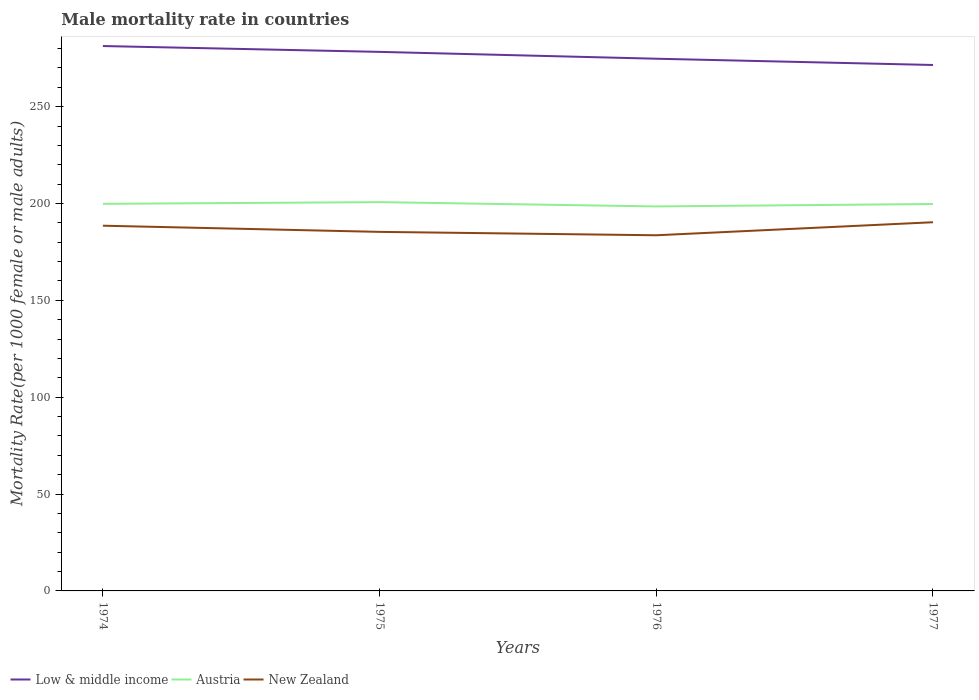How many different coloured lines are there?
Your answer should be compact. 3. Is the number of lines equal to the number of legend labels?
Your answer should be very brief. Yes. Across all years, what is the maximum male mortality rate in New Zealand?
Offer a terse response. 183.61. In which year was the male mortality rate in New Zealand maximum?
Ensure brevity in your answer.  1976. What is the total male mortality rate in Austria in the graph?
Provide a short and direct response. 2.21. What is the difference between the highest and the second highest male mortality rate in Low & middle income?
Provide a short and direct response. 9.78. What is the difference between the highest and the lowest male mortality rate in New Zealand?
Give a very brief answer. 2. How many years are there in the graph?
Make the answer very short. 4. What is the difference between two consecutive major ticks on the Y-axis?
Your answer should be compact. 50. Does the graph contain grids?
Offer a very short reply. No. What is the title of the graph?
Your answer should be compact. Male mortality rate in countries. What is the label or title of the X-axis?
Offer a very short reply. Years. What is the label or title of the Y-axis?
Offer a very short reply. Mortality Rate(per 1000 female or male adults). What is the Mortality Rate(per 1000 female or male adults) of Low & middle income in 1974?
Ensure brevity in your answer.  281.3. What is the Mortality Rate(per 1000 female or male adults) in Austria in 1974?
Give a very brief answer. 199.84. What is the Mortality Rate(per 1000 female or male adults) of New Zealand in 1974?
Provide a succinct answer. 188.54. What is the Mortality Rate(per 1000 female or male adults) of Low & middle income in 1975?
Ensure brevity in your answer.  278.28. What is the Mortality Rate(per 1000 female or male adults) of Austria in 1975?
Make the answer very short. 200.71. What is the Mortality Rate(per 1000 female or male adults) in New Zealand in 1975?
Keep it short and to the point. 185.37. What is the Mortality Rate(per 1000 female or male adults) in Low & middle income in 1976?
Your answer should be compact. 274.75. What is the Mortality Rate(per 1000 female or male adults) in Austria in 1976?
Keep it short and to the point. 198.5. What is the Mortality Rate(per 1000 female or male adults) in New Zealand in 1976?
Provide a short and direct response. 183.61. What is the Mortality Rate(per 1000 female or male adults) of Low & middle income in 1977?
Provide a succinct answer. 271.52. What is the Mortality Rate(per 1000 female or male adults) of Austria in 1977?
Give a very brief answer. 199.75. What is the Mortality Rate(per 1000 female or male adults) in New Zealand in 1977?
Your answer should be very brief. 190.34. Across all years, what is the maximum Mortality Rate(per 1000 female or male adults) of Low & middle income?
Provide a short and direct response. 281.3. Across all years, what is the maximum Mortality Rate(per 1000 female or male adults) of Austria?
Your answer should be compact. 200.71. Across all years, what is the maximum Mortality Rate(per 1000 female or male adults) in New Zealand?
Your answer should be very brief. 190.34. Across all years, what is the minimum Mortality Rate(per 1000 female or male adults) in Low & middle income?
Make the answer very short. 271.52. Across all years, what is the minimum Mortality Rate(per 1000 female or male adults) in Austria?
Your response must be concise. 198.5. Across all years, what is the minimum Mortality Rate(per 1000 female or male adults) of New Zealand?
Provide a short and direct response. 183.61. What is the total Mortality Rate(per 1000 female or male adults) of Low & middle income in the graph?
Your answer should be very brief. 1105.86. What is the total Mortality Rate(per 1000 female or male adults) in Austria in the graph?
Keep it short and to the point. 798.8. What is the total Mortality Rate(per 1000 female or male adults) of New Zealand in the graph?
Your answer should be compact. 747.85. What is the difference between the Mortality Rate(per 1000 female or male adults) of Low & middle income in 1974 and that in 1975?
Offer a very short reply. 3.02. What is the difference between the Mortality Rate(per 1000 female or male adults) in Austria in 1974 and that in 1975?
Offer a terse response. -0.87. What is the difference between the Mortality Rate(per 1000 female or male adults) in New Zealand in 1974 and that in 1975?
Give a very brief answer. 3.18. What is the difference between the Mortality Rate(per 1000 female or male adults) of Low & middle income in 1974 and that in 1976?
Provide a succinct answer. 6.55. What is the difference between the Mortality Rate(per 1000 female or male adults) in Austria in 1974 and that in 1976?
Keep it short and to the point. 1.33. What is the difference between the Mortality Rate(per 1000 female or male adults) of New Zealand in 1974 and that in 1976?
Ensure brevity in your answer.  4.93. What is the difference between the Mortality Rate(per 1000 female or male adults) in Low & middle income in 1974 and that in 1977?
Your response must be concise. 9.78. What is the difference between the Mortality Rate(per 1000 female or male adults) in Austria in 1974 and that in 1977?
Make the answer very short. 0.09. What is the difference between the Mortality Rate(per 1000 female or male adults) of New Zealand in 1974 and that in 1977?
Make the answer very short. -1.79. What is the difference between the Mortality Rate(per 1000 female or male adults) of Low & middle income in 1975 and that in 1976?
Make the answer very short. 3.53. What is the difference between the Mortality Rate(per 1000 female or male adults) of Austria in 1975 and that in 1976?
Provide a short and direct response. 2.21. What is the difference between the Mortality Rate(per 1000 female or male adults) of New Zealand in 1975 and that in 1976?
Your response must be concise. 1.76. What is the difference between the Mortality Rate(per 1000 female or male adults) in Low & middle income in 1975 and that in 1977?
Offer a very short reply. 6.77. What is the difference between the Mortality Rate(per 1000 female or male adults) in New Zealand in 1975 and that in 1977?
Provide a short and direct response. -4.97. What is the difference between the Mortality Rate(per 1000 female or male adults) in Low & middle income in 1976 and that in 1977?
Your answer should be very brief. 3.23. What is the difference between the Mortality Rate(per 1000 female or male adults) of Austria in 1976 and that in 1977?
Provide a short and direct response. -1.24. What is the difference between the Mortality Rate(per 1000 female or male adults) of New Zealand in 1976 and that in 1977?
Offer a very short reply. -6.73. What is the difference between the Mortality Rate(per 1000 female or male adults) in Low & middle income in 1974 and the Mortality Rate(per 1000 female or male adults) in Austria in 1975?
Provide a short and direct response. 80.59. What is the difference between the Mortality Rate(per 1000 female or male adults) in Low & middle income in 1974 and the Mortality Rate(per 1000 female or male adults) in New Zealand in 1975?
Make the answer very short. 95.94. What is the difference between the Mortality Rate(per 1000 female or male adults) in Austria in 1974 and the Mortality Rate(per 1000 female or male adults) in New Zealand in 1975?
Give a very brief answer. 14.47. What is the difference between the Mortality Rate(per 1000 female or male adults) of Low & middle income in 1974 and the Mortality Rate(per 1000 female or male adults) of Austria in 1976?
Offer a very short reply. 82.8. What is the difference between the Mortality Rate(per 1000 female or male adults) in Low & middle income in 1974 and the Mortality Rate(per 1000 female or male adults) in New Zealand in 1976?
Offer a terse response. 97.69. What is the difference between the Mortality Rate(per 1000 female or male adults) of Austria in 1974 and the Mortality Rate(per 1000 female or male adults) of New Zealand in 1976?
Your response must be concise. 16.23. What is the difference between the Mortality Rate(per 1000 female or male adults) in Low & middle income in 1974 and the Mortality Rate(per 1000 female or male adults) in Austria in 1977?
Provide a succinct answer. 81.56. What is the difference between the Mortality Rate(per 1000 female or male adults) in Low & middle income in 1974 and the Mortality Rate(per 1000 female or male adults) in New Zealand in 1977?
Keep it short and to the point. 90.97. What is the difference between the Mortality Rate(per 1000 female or male adults) of Austria in 1974 and the Mortality Rate(per 1000 female or male adults) of New Zealand in 1977?
Give a very brief answer. 9.5. What is the difference between the Mortality Rate(per 1000 female or male adults) of Low & middle income in 1975 and the Mortality Rate(per 1000 female or male adults) of Austria in 1976?
Give a very brief answer. 79.78. What is the difference between the Mortality Rate(per 1000 female or male adults) in Low & middle income in 1975 and the Mortality Rate(per 1000 female or male adults) in New Zealand in 1976?
Provide a short and direct response. 94.68. What is the difference between the Mortality Rate(per 1000 female or male adults) of Austria in 1975 and the Mortality Rate(per 1000 female or male adults) of New Zealand in 1976?
Provide a succinct answer. 17.1. What is the difference between the Mortality Rate(per 1000 female or male adults) in Low & middle income in 1975 and the Mortality Rate(per 1000 female or male adults) in Austria in 1977?
Offer a terse response. 78.54. What is the difference between the Mortality Rate(per 1000 female or male adults) of Low & middle income in 1975 and the Mortality Rate(per 1000 female or male adults) of New Zealand in 1977?
Offer a very short reply. 87.95. What is the difference between the Mortality Rate(per 1000 female or male adults) of Austria in 1975 and the Mortality Rate(per 1000 female or male adults) of New Zealand in 1977?
Provide a short and direct response. 10.37. What is the difference between the Mortality Rate(per 1000 female or male adults) in Low & middle income in 1976 and the Mortality Rate(per 1000 female or male adults) in Austria in 1977?
Offer a terse response. 75.01. What is the difference between the Mortality Rate(per 1000 female or male adults) of Low & middle income in 1976 and the Mortality Rate(per 1000 female or male adults) of New Zealand in 1977?
Provide a short and direct response. 84.42. What is the difference between the Mortality Rate(per 1000 female or male adults) of Austria in 1976 and the Mortality Rate(per 1000 female or male adults) of New Zealand in 1977?
Provide a succinct answer. 8.17. What is the average Mortality Rate(per 1000 female or male adults) of Low & middle income per year?
Give a very brief answer. 276.46. What is the average Mortality Rate(per 1000 female or male adults) in Austria per year?
Offer a very short reply. 199.7. What is the average Mortality Rate(per 1000 female or male adults) of New Zealand per year?
Offer a very short reply. 186.96. In the year 1974, what is the difference between the Mortality Rate(per 1000 female or male adults) of Low & middle income and Mortality Rate(per 1000 female or male adults) of Austria?
Keep it short and to the point. 81.46. In the year 1974, what is the difference between the Mortality Rate(per 1000 female or male adults) in Low & middle income and Mortality Rate(per 1000 female or male adults) in New Zealand?
Your answer should be compact. 92.76. In the year 1974, what is the difference between the Mortality Rate(per 1000 female or male adults) of Austria and Mortality Rate(per 1000 female or male adults) of New Zealand?
Provide a succinct answer. 11.29. In the year 1975, what is the difference between the Mortality Rate(per 1000 female or male adults) in Low & middle income and Mortality Rate(per 1000 female or male adults) in Austria?
Ensure brevity in your answer.  77.57. In the year 1975, what is the difference between the Mortality Rate(per 1000 female or male adults) of Low & middle income and Mortality Rate(per 1000 female or male adults) of New Zealand?
Ensure brevity in your answer.  92.92. In the year 1975, what is the difference between the Mortality Rate(per 1000 female or male adults) of Austria and Mortality Rate(per 1000 female or male adults) of New Zealand?
Offer a terse response. 15.35. In the year 1976, what is the difference between the Mortality Rate(per 1000 female or male adults) in Low & middle income and Mortality Rate(per 1000 female or male adults) in Austria?
Your answer should be very brief. 76.25. In the year 1976, what is the difference between the Mortality Rate(per 1000 female or male adults) of Low & middle income and Mortality Rate(per 1000 female or male adults) of New Zealand?
Ensure brevity in your answer.  91.14. In the year 1976, what is the difference between the Mortality Rate(per 1000 female or male adults) of Austria and Mortality Rate(per 1000 female or male adults) of New Zealand?
Keep it short and to the point. 14.89. In the year 1977, what is the difference between the Mortality Rate(per 1000 female or male adults) of Low & middle income and Mortality Rate(per 1000 female or male adults) of Austria?
Your answer should be very brief. 71.77. In the year 1977, what is the difference between the Mortality Rate(per 1000 female or male adults) of Low & middle income and Mortality Rate(per 1000 female or male adults) of New Zealand?
Provide a succinct answer. 81.18. In the year 1977, what is the difference between the Mortality Rate(per 1000 female or male adults) in Austria and Mortality Rate(per 1000 female or male adults) in New Zealand?
Give a very brief answer. 9.41. What is the ratio of the Mortality Rate(per 1000 female or male adults) in Low & middle income in 1974 to that in 1975?
Provide a succinct answer. 1.01. What is the ratio of the Mortality Rate(per 1000 female or male adults) in Austria in 1974 to that in 1975?
Provide a short and direct response. 1. What is the ratio of the Mortality Rate(per 1000 female or male adults) in New Zealand in 1974 to that in 1975?
Provide a short and direct response. 1.02. What is the ratio of the Mortality Rate(per 1000 female or male adults) of Low & middle income in 1974 to that in 1976?
Provide a short and direct response. 1.02. What is the ratio of the Mortality Rate(per 1000 female or male adults) of New Zealand in 1974 to that in 1976?
Offer a very short reply. 1.03. What is the ratio of the Mortality Rate(per 1000 female or male adults) of Low & middle income in 1974 to that in 1977?
Keep it short and to the point. 1.04. What is the ratio of the Mortality Rate(per 1000 female or male adults) in New Zealand in 1974 to that in 1977?
Offer a terse response. 0.99. What is the ratio of the Mortality Rate(per 1000 female or male adults) in Low & middle income in 1975 to that in 1976?
Offer a terse response. 1.01. What is the ratio of the Mortality Rate(per 1000 female or male adults) in Austria in 1975 to that in 1976?
Provide a short and direct response. 1.01. What is the ratio of the Mortality Rate(per 1000 female or male adults) of New Zealand in 1975 to that in 1976?
Provide a succinct answer. 1.01. What is the ratio of the Mortality Rate(per 1000 female or male adults) of Low & middle income in 1975 to that in 1977?
Offer a very short reply. 1.02. What is the ratio of the Mortality Rate(per 1000 female or male adults) in Austria in 1975 to that in 1977?
Provide a short and direct response. 1. What is the ratio of the Mortality Rate(per 1000 female or male adults) in New Zealand in 1975 to that in 1977?
Ensure brevity in your answer.  0.97. What is the ratio of the Mortality Rate(per 1000 female or male adults) of Low & middle income in 1976 to that in 1977?
Provide a short and direct response. 1.01. What is the ratio of the Mortality Rate(per 1000 female or male adults) of Austria in 1976 to that in 1977?
Keep it short and to the point. 0.99. What is the ratio of the Mortality Rate(per 1000 female or male adults) in New Zealand in 1976 to that in 1977?
Provide a succinct answer. 0.96. What is the difference between the highest and the second highest Mortality Rate(per 1000 female or male adults) of Low & middle income?
Give a very brief answer. 3.02. What is the difference between the highest and the second highest Mortality Rate(per 1000 female or male adults) in Austria?
Make the answer very short. 0.87. What is the difference between the highest and the second highest Mortality Rate(per 1000 female or male adults) of New Zealand?
Give a very brief answer. 1.79. What is the difference between the highest and the lowest Mortality Rate(per 1000 female or male adults) of Low & middle income?
Make the answer very short. 9.78. What is the difference between the highest and the lowest Mortality Rate(per 1000 female or male adults) in Austria?
Provide a succinct answer. 2.21. What is the difference between the highest and the lowest Mortality Rate(per 1000 female or male adults) in New Zealand?
Your response must be concise. 6.73. 